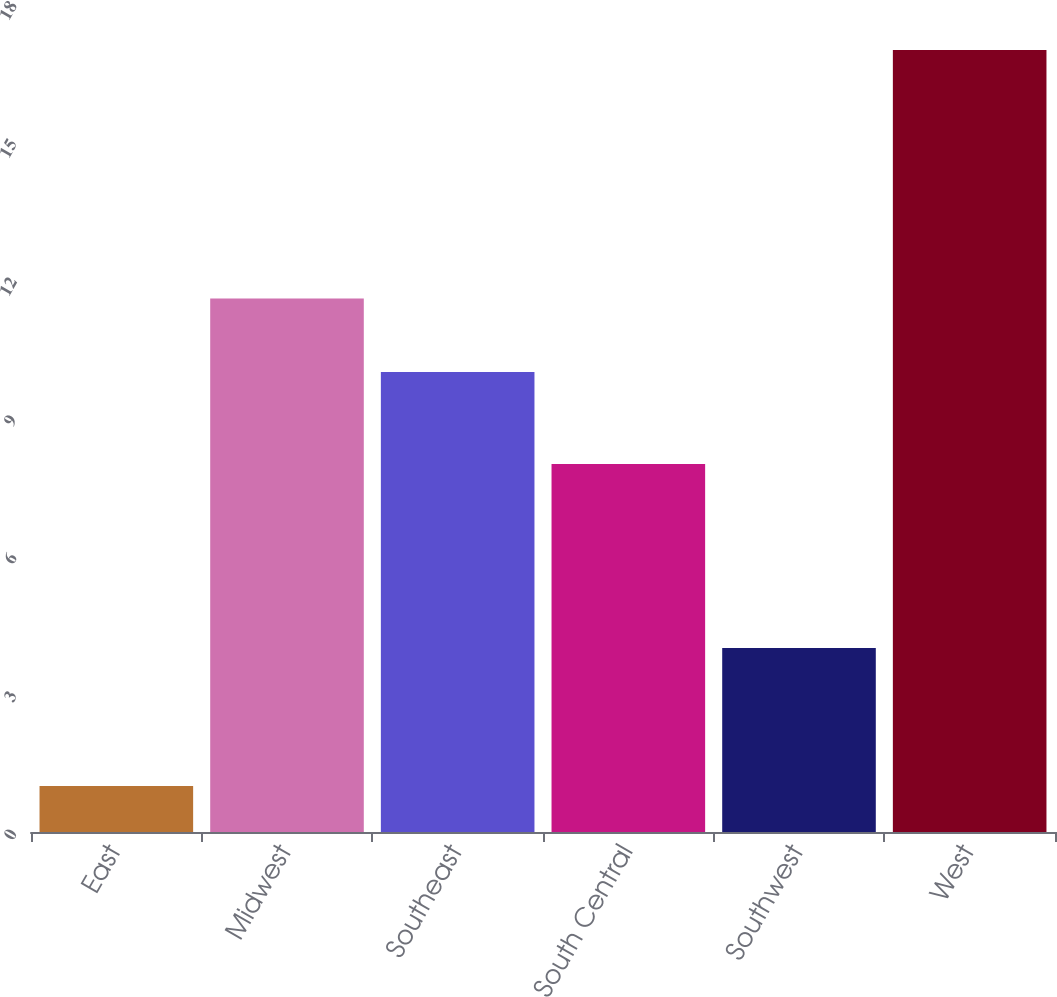<chart> <loc_0><loc_0><loc_500><loc_500><bar_chart><fcel>East<fcel>Midwest<fcel>Southeast<fcel>South Central<fcel>Southwest<fcel>West<nl><fcel>1<fcel>11.6<fcel>10<fcel>8<fcel>4<fcel>17<nl></chart> 